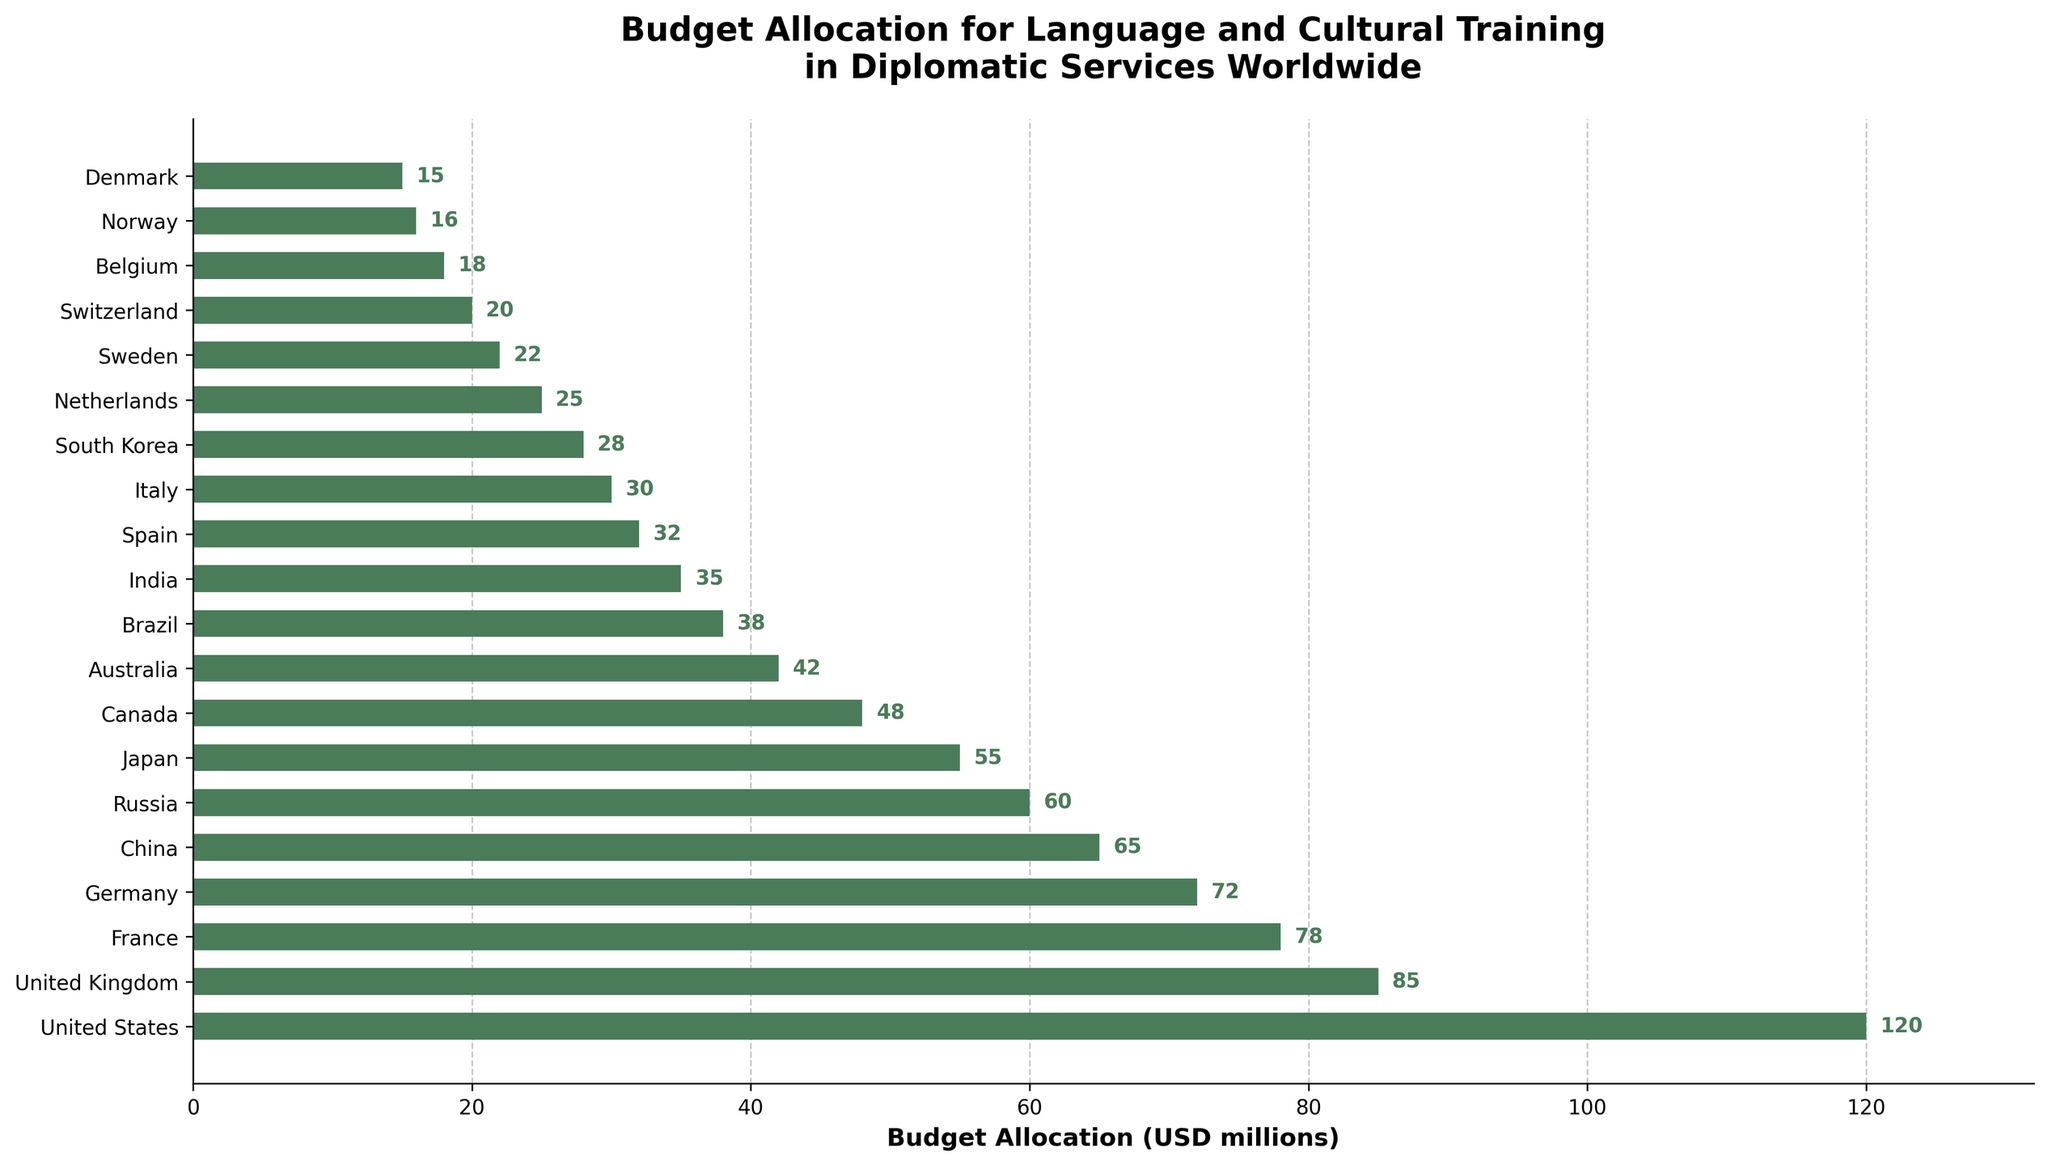Which country has the highest budget allocation for language and cultural training? The highest bar on the chart represents the United States with a budget allocation of 120 million USD.
Answer: United States Which country has the lowest budget allocation for language and cultural training? The shortest bar on the chart represents Denmark with a budget allocation of 15 million USD.
Answer: Denmark What is the total budget allocation for the top three countries combined? The top three countries are the United States, the United Kingdom, and France. Their budget allocations are 120, 85, and 78 million USD respectively. Adding these gives 120 + 85 + 78 = 283 million USD.
Answer: 283 How does the budget allocation of China compare to Japan? The bar for China is higher than the bar for Japan, indicating a higher budget allocation. China has 65 million USD, while Japan has 55 million USD.
Answer: China has a higher allocation Is the budget allocation of Italy closer to the allocation of Spain or South Korea? Italy has a budget allocation of 30 million USD. Spain has 32 million USD, while South Korea has 28 million USD. The difference between Italy and Spain is 2 million USD (32 - 30), and between Italy and South Korea is 2 million USD (30 - 28).
Answer: Equally close Which countries have a budget allocation lower than 20 million USD? By looking at the bars that are shorter than 20 million USD, we identify Belgium, Norway, and Denmark with allocations of 18, 16, and 15 million USD respectively.
Answer: Belgium, Norway, Denmark What is the average budget allocation for all the countries listed? Sum all the budget allocations and divide by the number of countries. The total allocation is 120+85+78+72+65+60+55+48+42+38+35+32+30+28+25+22+20+18+16+15 = 934 million USD. There are 20 countries, so the average is 934/20 = 46.7 million USD.
Answer: 46.7 How much more does Canada spend on language and cultural training than Australia? Canada’s budget allocation is 48 million USD, while Australia’s is 42 million USD. The difference is 48 - 42 = 6 million USD.
Answer: 6 What is the difference in budget allocation between Germany and France? Germany’s budget allocation is 72 million USD and France’s is 78 million USD. The difference is 78 - 72 = 6 million USD.
Answer: 6 